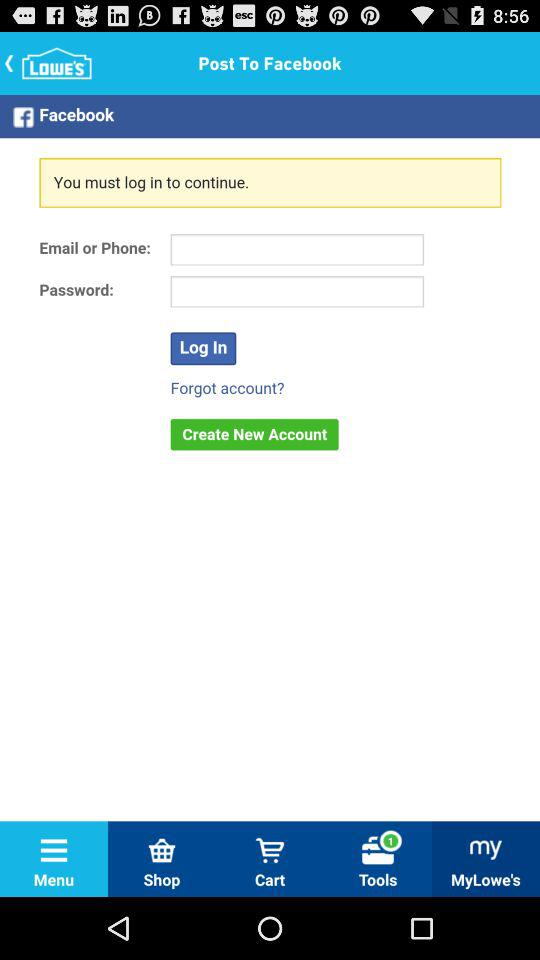Which application are we accessing? You are accessing "Facebook". 